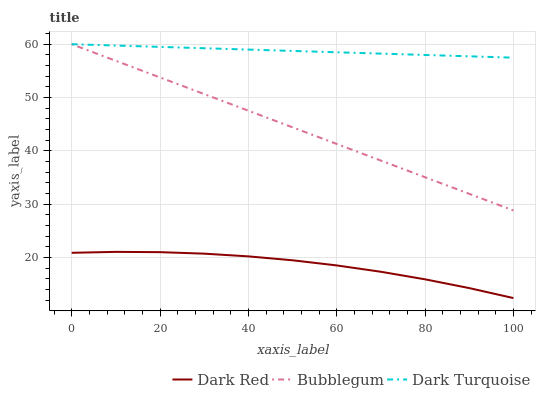Does Dark Red have the minimum area under the curve?
Answer yes or no. Yes. Does Dark Turquoise have the maximum area under the curve?
Answer yes or no. Yes. Does Bubblegum have the minimum area under the curve?
Answer yes or no. No. Does Bubblegum have the maximum area under the curve?
Answer yes or no. No. Is Bubblegum the smoothest?
Answer yes or no. Yes. Is Dark Red the roughest?
Answer yes or no. Yes. Is Dark Turquoise the smoothest?
Answer yes or no. No. Is Dark Turquoise the roughest?
Answer yes or no. No. Does Bubblegum have the lowest value?
Answer yes or no. No. Is Dark Red less than Bubblegum?
Answer yes or no. Yes. Is Bubblegum greater than Dark Red?
Answer yes or no. Yes. Does Dark Red intersect Bubblegum?
Answer yes or no. No. 